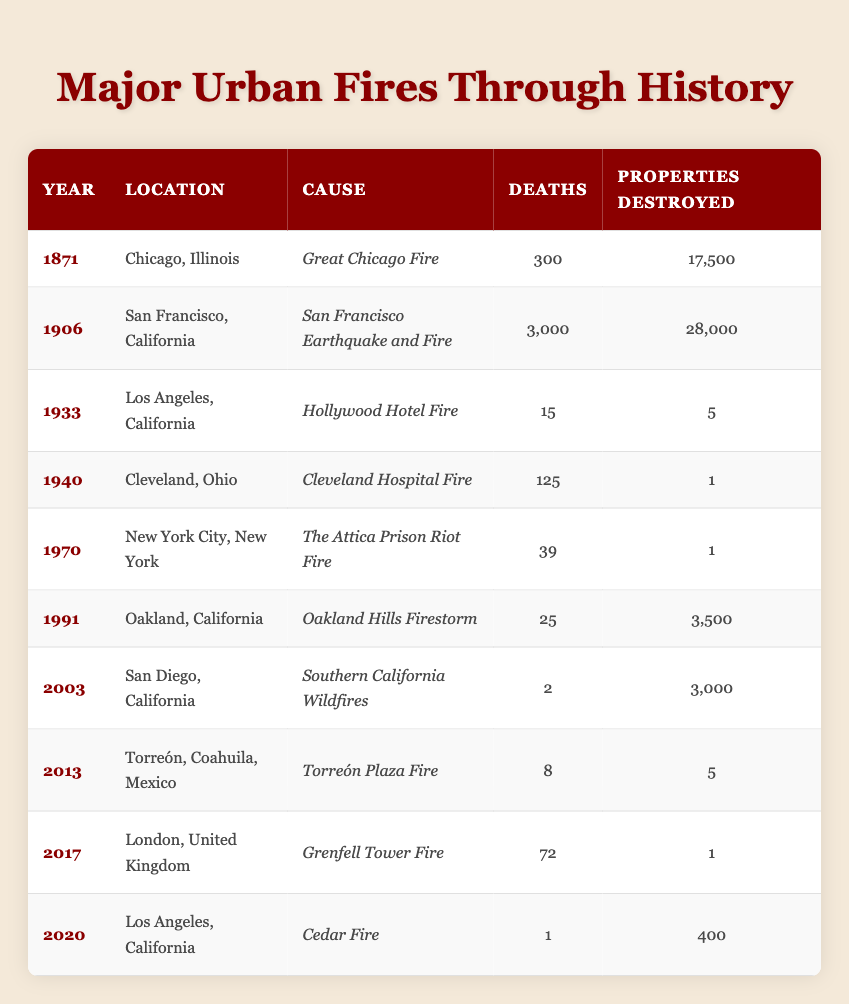What year did the Great Chicago Fire occur? The Great Chicago Fire is listed in the table under the row for Chicago, Illinois, and its corresponding year is 1871.
Answer: 1871 How many properties were destroyed in the San Francisco Earthquake and Fire? The table indicates that during the San Francisco Earthquake and Fire in 1906, the number of properties destroyed was 28,000.
Answer: 28,000 Which incident resulted in the highest number of deaths? To find the highest number of deaths, compare the deaths across all rows. The San Francisco Earthquake and Fire (1906) had 3,000 deaths, which is more than any other incident listed.
Answer: 3,000 What is the total number of deaths from urban fires in the 20th century listed in the table? Adding the deaths from the relevant incidents: 3,000 (San Francisco) + 15 (Los Angeles) + 125 (Cleveland) + 39 (New York City) + 25 (Oakland) + 2 (San Diego) gives a total of 3,206 deaths.
Answer: 3,206 Did any of the fires result in more than 70 deaths? From the table, only the San Francisco Earthquake and Fire (3,000 deaths) exceeds 70 deaths. Hence, the answer is yes.
Answer: Yes What was the average number of properties destroyed in the incidents listed after 2000? The relevant incidents are the Southern California Wildfires (3,000 properties), Torreón Plaza Fire (5 properties), and Cedar Fire (400 properties). Their average is calculated as (3,000 + 5 + 400) / 3 = 1,468.33.
Answer: 1,468.33 Which fire caused the least number of deaths, and what was the year? Looking at the table, the incident with the least number of deaths is the Cedar Fire in 2020, with only 1 death recorded.
Answer: Cedar Fire, 2020 How many incidents resulted in the destruction of only one property? The table shows that there are two incidents where only one property was destroyed: Cleveland Hospital Fire (1940) and The Attica Prison Riot Fire (1970), totaling two incidents.
Answer: 2 What is the difference in the number of properties destroyed between the Great Chicago Fire and the Oakland Hills Firestorm? The Great Chicago Fire destroyed 17,500 properties, and the Oakland Hills Firestorm destroyed 3,500 properties. The difference is 17,500 - 3,500 = 14,000 properties.
Answer: 14,000 